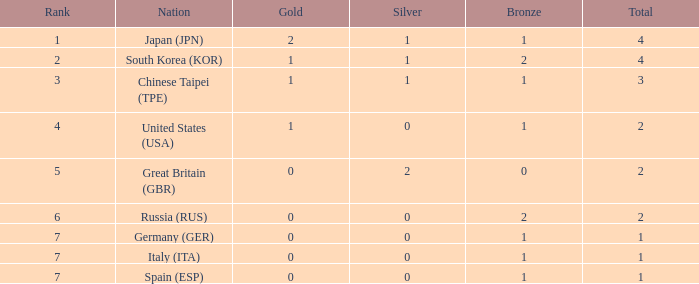How many total medals does a country with more than 1 silver medals have? 2.0. 